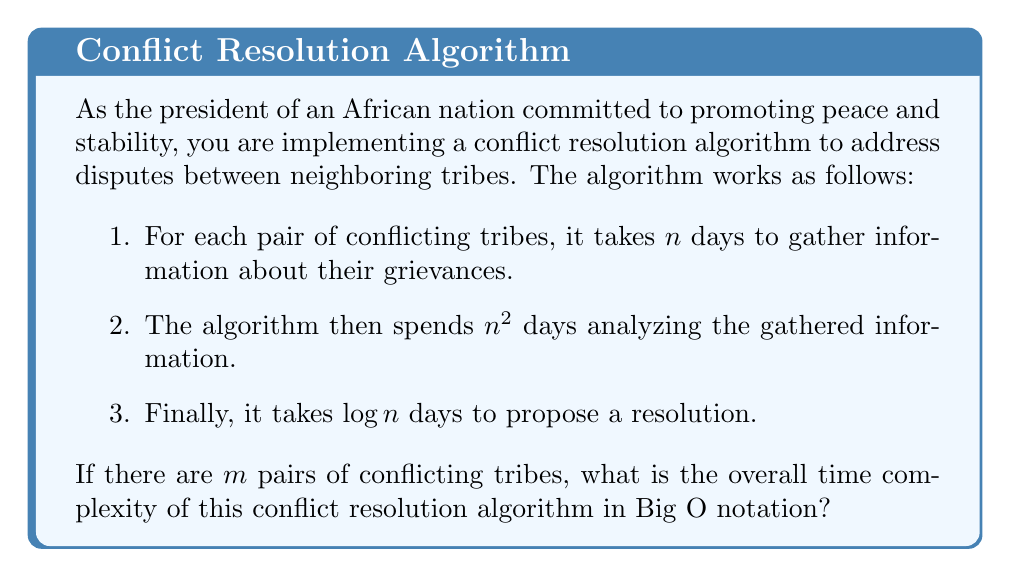Show me your answer to this math problem. To determine the overall time complexity, we need to analyze each step of the algorithm:

1. Gathering information:
   - This step takes $n$ days for each pair of conflicting tribes.
   - There are $m$ pairs of tribes.
   - Total time for this step: $O(mn)$

2. Analyzing information:
   - This step takes $n^2$ days for each pair of conflicting tribes.
   - There are $m$ pairs of tribes.
   - Total time for this step: $O(mn^2)$

3. Proposing resolution:
   - This step takes $\log n$ days for each pair of conflicting tribes.
   - There are $m$ pairs of tribes.
   - Total time for this step: $O(m \log n)$

To find the overall time complexity, we need to sum up the complexities of all steps:

$$O(mn) + O(mn^2) + O(m \log n)$$

In Big O notation, we consider the dominant term, which grows the fastest as $n$ increases. In this case, $n^2$ grows faster than both $n$ and $\log n$. Therefore, the dominant term is $O(mn^2)$.

Thus, the overall time complexity of the conflict resolution algorithm is $O(mn^2)$.
Answer: $O(mn^2)$ 